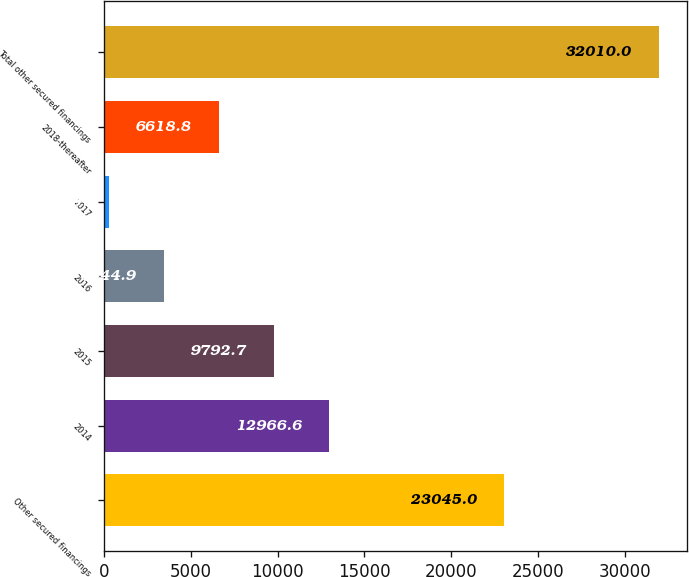<chart> <loc_0><loc_0><loc_500><loc_500><bar_chart><fcel>Other secured financings<fcel>2014<fcel>2015<fcel>2016<fcel>2017<fcel>2018-thereafter<fcel>Total other secured financings<nl><fcel>23045<fcel>12966.6<fcel>9792.7<fcel>3444.9<fcel>271<fcel>6618.8<fcel>32010<nl></chart> 